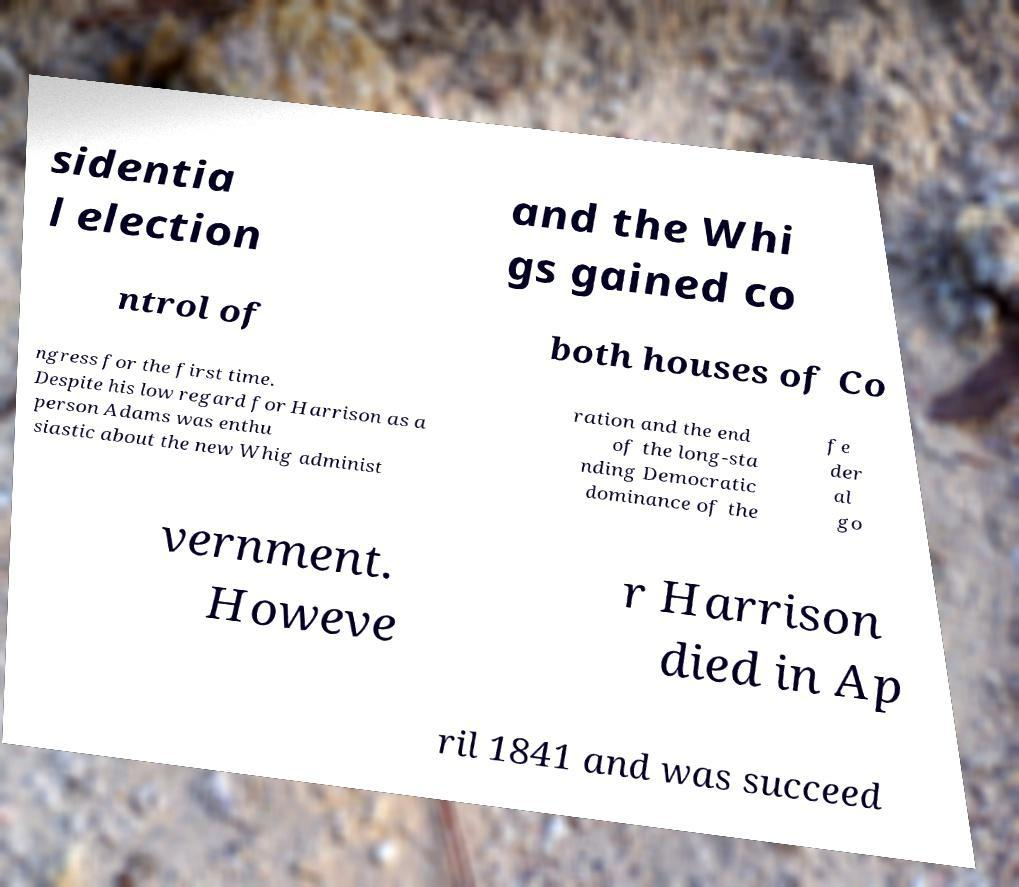What messages or text are displayed in this image? I need them in a readable, typed format. sidentia l election and the Whi gs gained co ntrol of both houses of Co ngress for the first time. Despite his low regard for Harrison as a person Adams was enthu siastic about the new Whig administ ration and the end of the long-sta nding Democratic dominance of the fe der al go vernment. Howeve r Harrison died in Ap ril 1841 and was succeed 